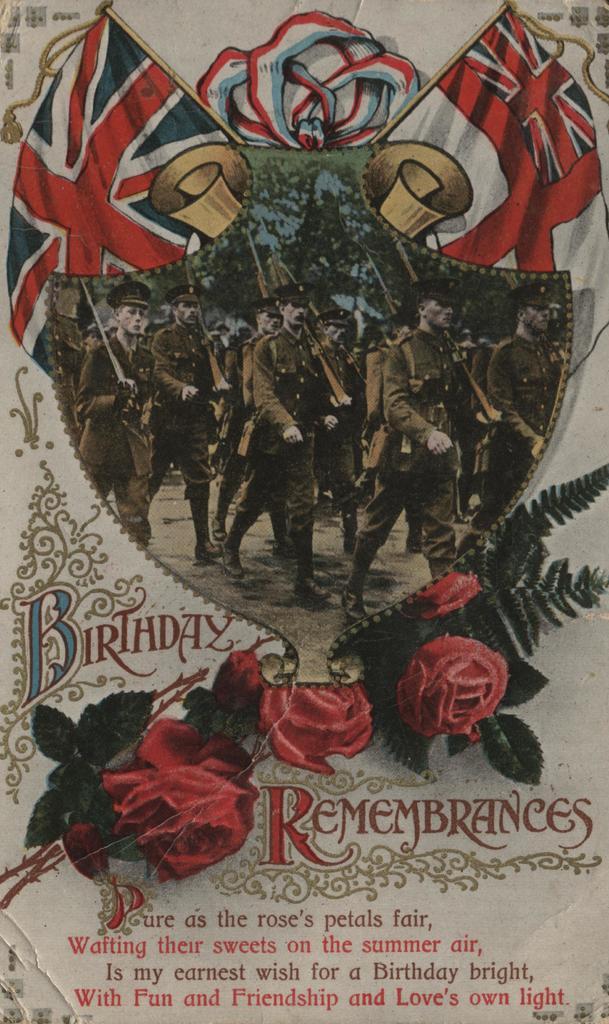Is the text written in poem form?
Your answer should be compact. Yes. What two words are around the roses?
Provide a short and direct response. Birthday remembrances. 